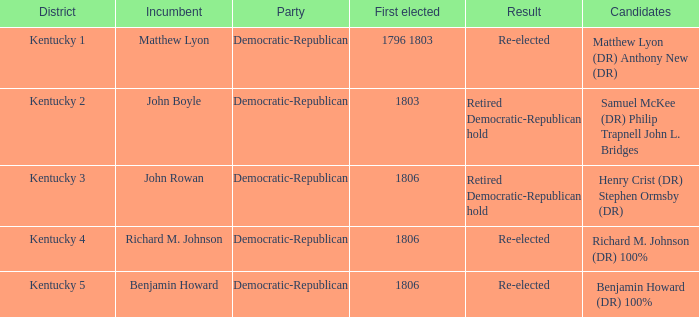Identify the first person elected in kentucky's third district. 1806.0. 